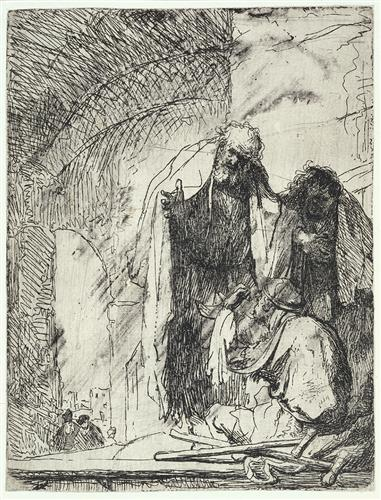Can you tell me more about the style and period of the artwork? The etching is executed with a strong sense of line and texture, which leans toward an expressionist style rather than the polished finish typical of the Baroque period. The period of the artwork isn't explicitly clear without more context, but the expressive quality could suggest a 19th or early 20th-century work, likely influenced by the Romantic or Expressionist movements, challenging the norms of earlier periods with a rawer emotional presentation. 